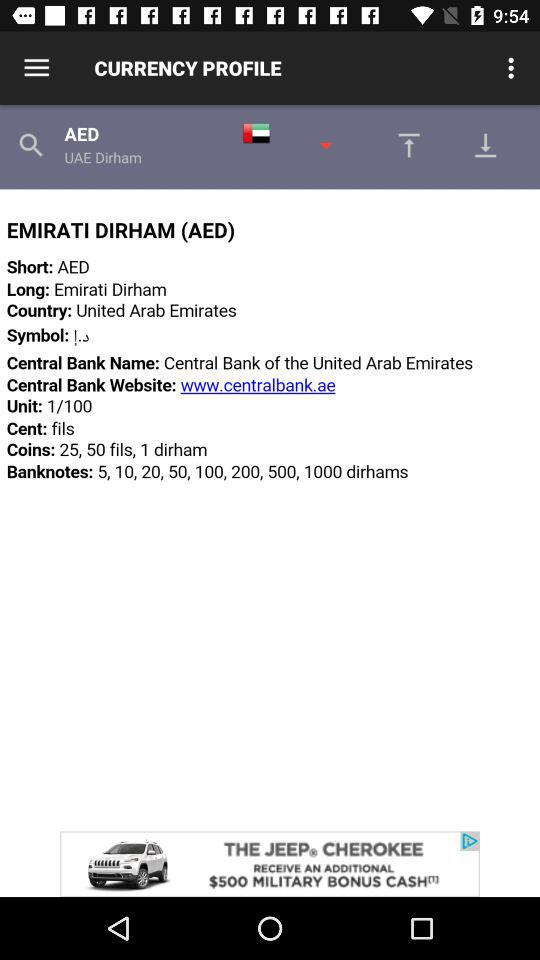What is the bank name that is used in the UAE country? The bank name that is used in the UAE country is "Central Bank of the United Arab Emirates". 